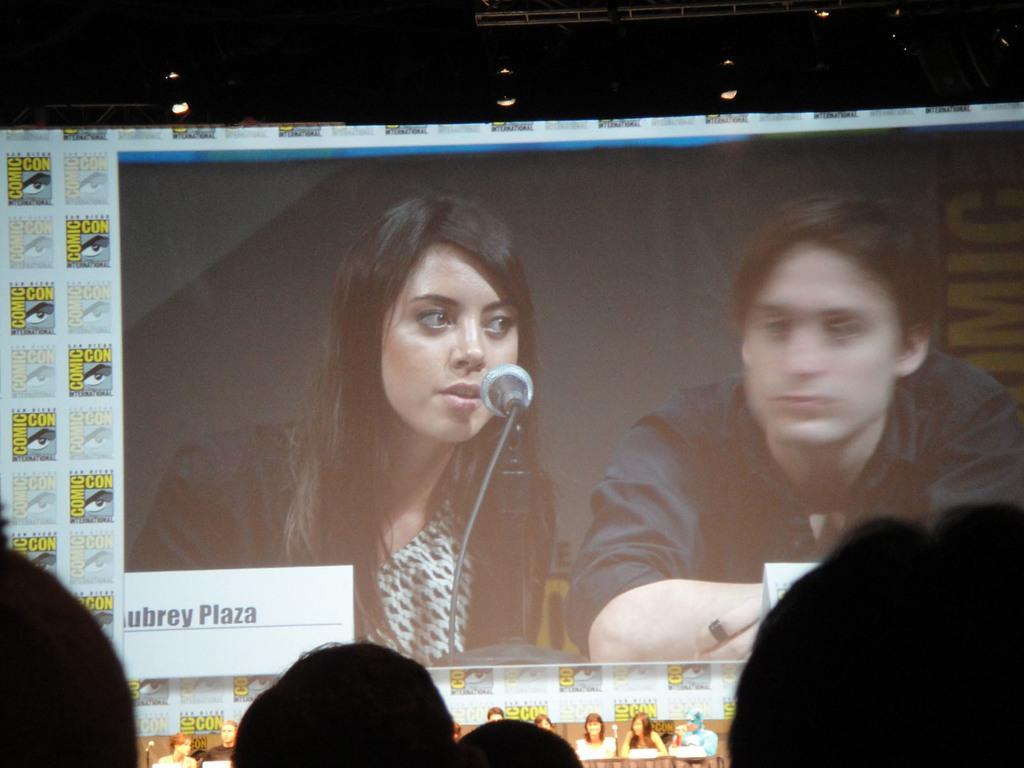Please provide a concise description of this image. In this image at the bottom we can see objects. In the background we can see screen and few persons are sitting at the table and at the top we can see lights, rods and other objects. 